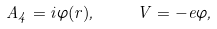<formula> <loc_0><loc_0><loc_500><loc_500>A _ { 4 } = i \varphi ( r ) , \quad V = - e \varphi ,</formula> 